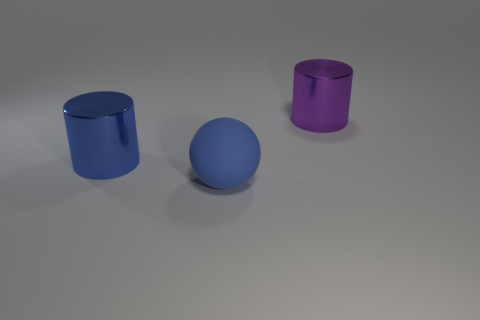Are there any other things that are the same material as the large blue sphere?
Provide a succinct answer. No. Is the number of blue shiny cylinders right of the big matte sphere less than the number of blue rubber things that are in front of the purple metallic cylinder?
Ensure brevity in your answer.  Yes. How many small objects are rubber spheres or cylinders?
Offer a very short reply. 0. Does the big blue thing that is behind the blue rubber object have the same shape as the metallic thing that is right of the blue sphere?
Give a very brief answer. Yes. There is a blue rubber ball that is in front of the large blue object that is behind the big object in front of the blue metallic cylinder; what size is it?
Ensure brevity in your answer.  Large. What is the size of the metallic thing right of the blue metal object?
Provide a succinct answer. Large. There is a ball to the left of the large purple thing; what is its material?
Your answer should be very brief. Rubber. How many green things are big objects or big shiny things?
Provide a succinct answer. 0. Is the material of the big ball the same as the large object that is on the right side of the big matte ball?
Make the answer very short. No. Are there the same number of big purple cylinders in front of the big blue rubber object and big cylinders that are to the right of the large blue cylinder?
Your response must be concise. No. 